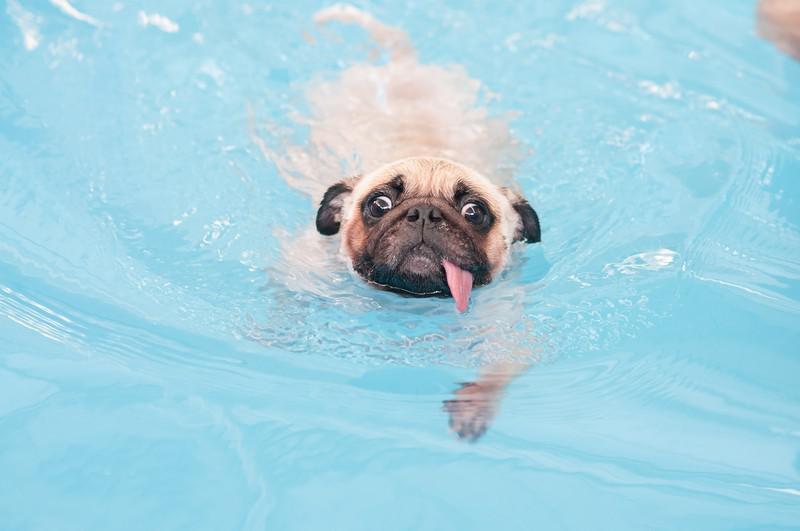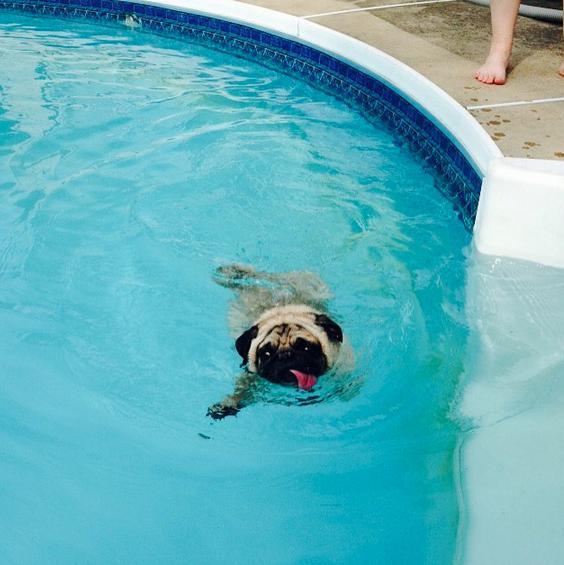The first image is the image on the left, the second image is the image on the right. Given the left and right images, does the statement "In both of the images there is a dog in a swimming pool." hold true? Answer yes or no. Yes. The first image is the image on the left, the second image is the image on the right. For the images displayed, is the sentence "Only one of the images shows a dog in the water." factually correct? Answer yes or no. No. 